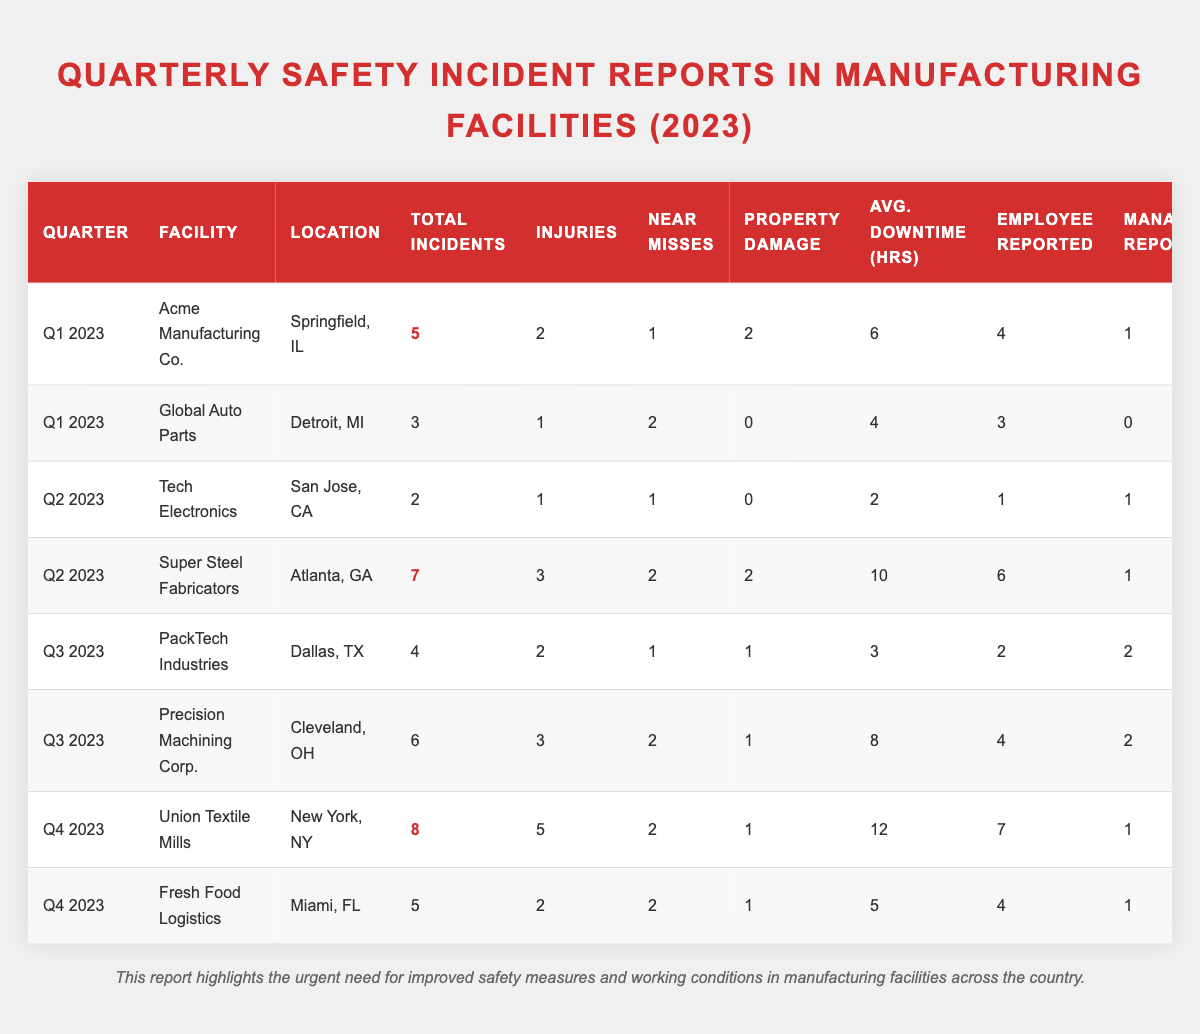What facility had the highest number of incidents in Q2 2023? In Q2 2023, Super Steel Fabricators had 7 incidents, which is the highest compared to Tech Electronics, which had only 2.
Answer: Super Steel Fabricators How many average downtime hours did Union Textile Mills report in Q4 2023? The average downtime hours for Union Textile Mills in Q4 2023 are 12 hours, as per the data in the table.
Answer: 12 hours What is the total number of incidents reported across all facilities in Q3 2023? In Q3 2023, PackTech Industries had 4 incidents and Precision Machining Corp. had 6 incidents, so total incidents = 4 + 6 = 10.
Answer: 10 Which facility reported more employee-reported incidents than management-reported incidents in Q1 2023? Acme Manufacturing Co. reported 4 employee-reported incidents and 1 management-reported incident, fulfilling the condition of more employee than management reports.
Answer: Acme Manufacturing Co What is the average number of injuries across all facilities for the first quarter of 2023? In Q1 2023, the total injuries reported were 2 (Acme Manufacturing Co.) + 1 (Global Auto Parts) = 3. The average is 3 incidents / 2 facilities = 1.5.
Answer: 1.5 Did Fresh Food Logistics have more total incidents or injuries in Q4 2023? Fresh Food Logistics reported 5 total incidents and 2 injuries, showing that total incidents are higher than injuries.
Answer: Total incidents are higher How many facilities reported a total of 6 incidents or more throughout 2023? The facilities with 6 or more incidents in 2023 are Super Steel Fabricators (7, Q2), Precision Machining Corp. (6, Q3), and Union Textile Mills (8, Q4), giving a total of 3 facilities.
Answer: 3 facilities What percentage of reported incidents were injuries at Super Steel Fabricators in Q2 2023? Super Steel Fabricators had 7 total incidents, with 3 being injuries. The percentage of injuries = (3 injuries / 7 total incidents) x 100 = 42.86%.
Answer: 42.86% Which period had the least average downtime based on the reported data? The least average downtime hours are recorded for Tech Electronics in Q2 2023, which is 2 hours.
Answer: Q2 2023 In Q4 2023, which facility had the highest number of injuries? Union Textile Mills had the highest number of injuries in Q4 2023 with 5 reported injuries.
Answer: Union Textile Mills 